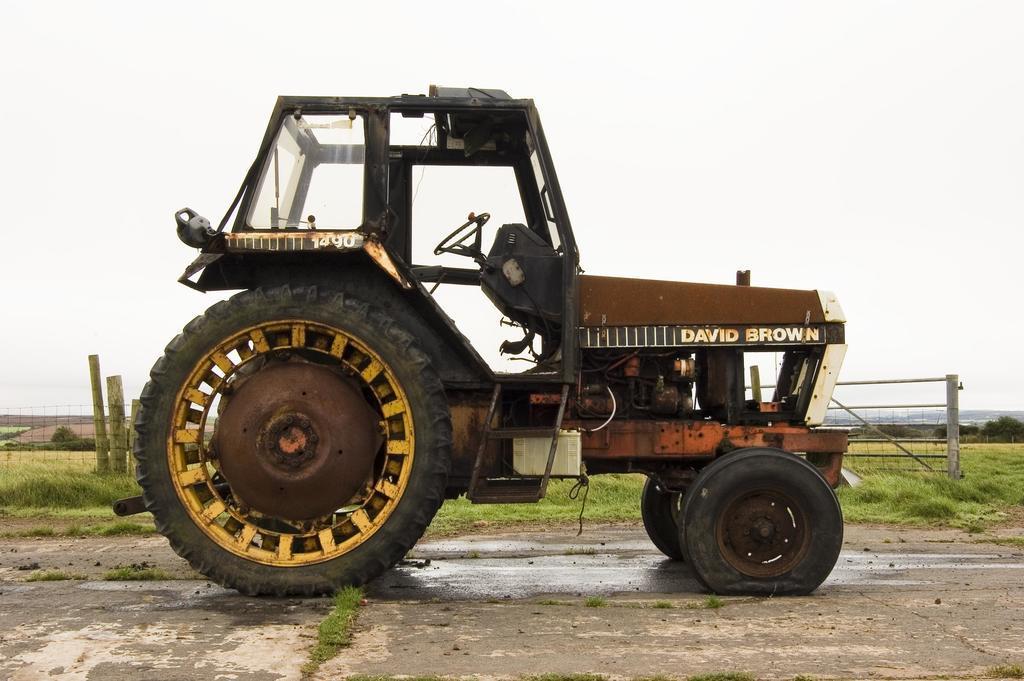Describe this image in one or two sentences. In the middle of the image we can see vehicle. In the background of the image there is a mesh, wooden logs, grass, trees and sky. 